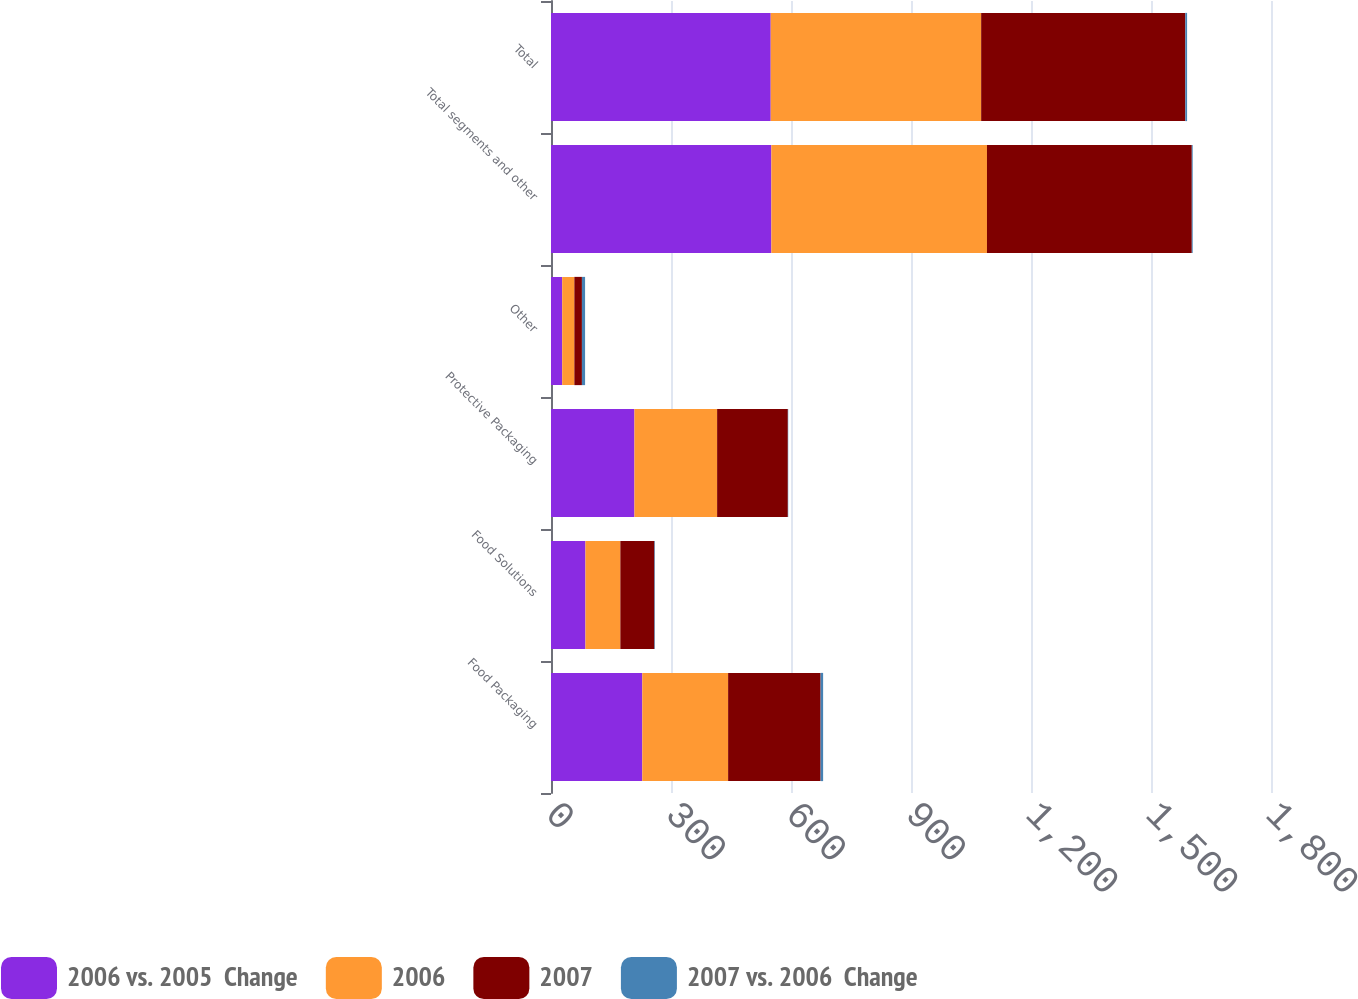Convert chart. <chart><loc_0><loc_0><loc_500><loc_500><stacked_bar_chart><ecel><fcel>Food Packaging<fcel>Food Solutions<fcel>Protective Packaging<fcel>Other<fcel>Total segments and other<fcel>Total<nl><fcel>2006 vs. 2005  Change<fcel>228.2<fcel>86.1<fcel>208.6<fcel>28<fcel>550.9<fcel>549.3<nl><fcel>2006<fcel>214.6<fcel>87.3<fcel>206.7<fcel>30.4<fcel>539<fcel>526.1<nl><fcel>2007<fcel>231.2<fcel>85.2<fcel>176.8<fcel>18.9<fcel>512.1<fcel>510.4<nl><fcel>2007 vs. 2006  Change<fcel>6.3<fcel>1.4<fcel>0.9<fcel>7.9<fcel>2.2<fcel>4.4<nl></chart> 